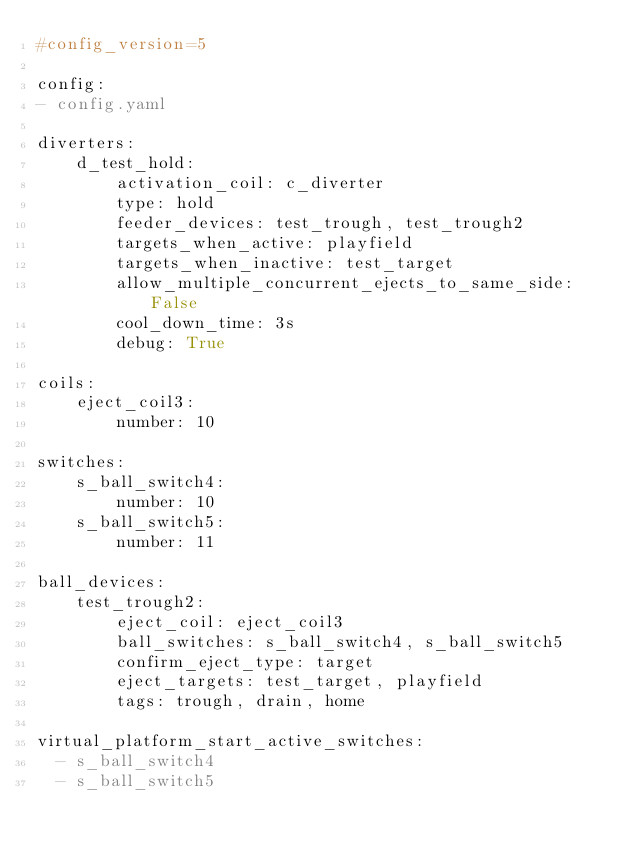<code> <loc_0><loc_0><loc_500><loc_500><_YAML_>#config_version=5

config:
- config.yaml

diverters:
    d_test_hold:
        activation_coil: c_diverter
        type: hold
        feeder_devices: test_trough, test_trough2
        targets_when_active: playfield
        targets_when_inactive: test_target
        allow_multiple_concurrent_ejects_to_same_side: False
        cool_down_time: 3s
        debug: True

coils:
    eject_coil3:
        number: 10

switches:
    s_ball_switch4:
        number: 10
    s_ball_switch5:
        number: 11

ball_devices:
    test_trough2:
        eject_coil: eject_coil3
        ball_switches: s_ball_switch4, s_ball_switch5
        confirm_eject_type: target
        eject_targets: test_target, playfield
        tags: trough, drain, home

virtual_platform_start_active_switches:
  - s_ball_switch4
  - s_ball_switch5</code> 